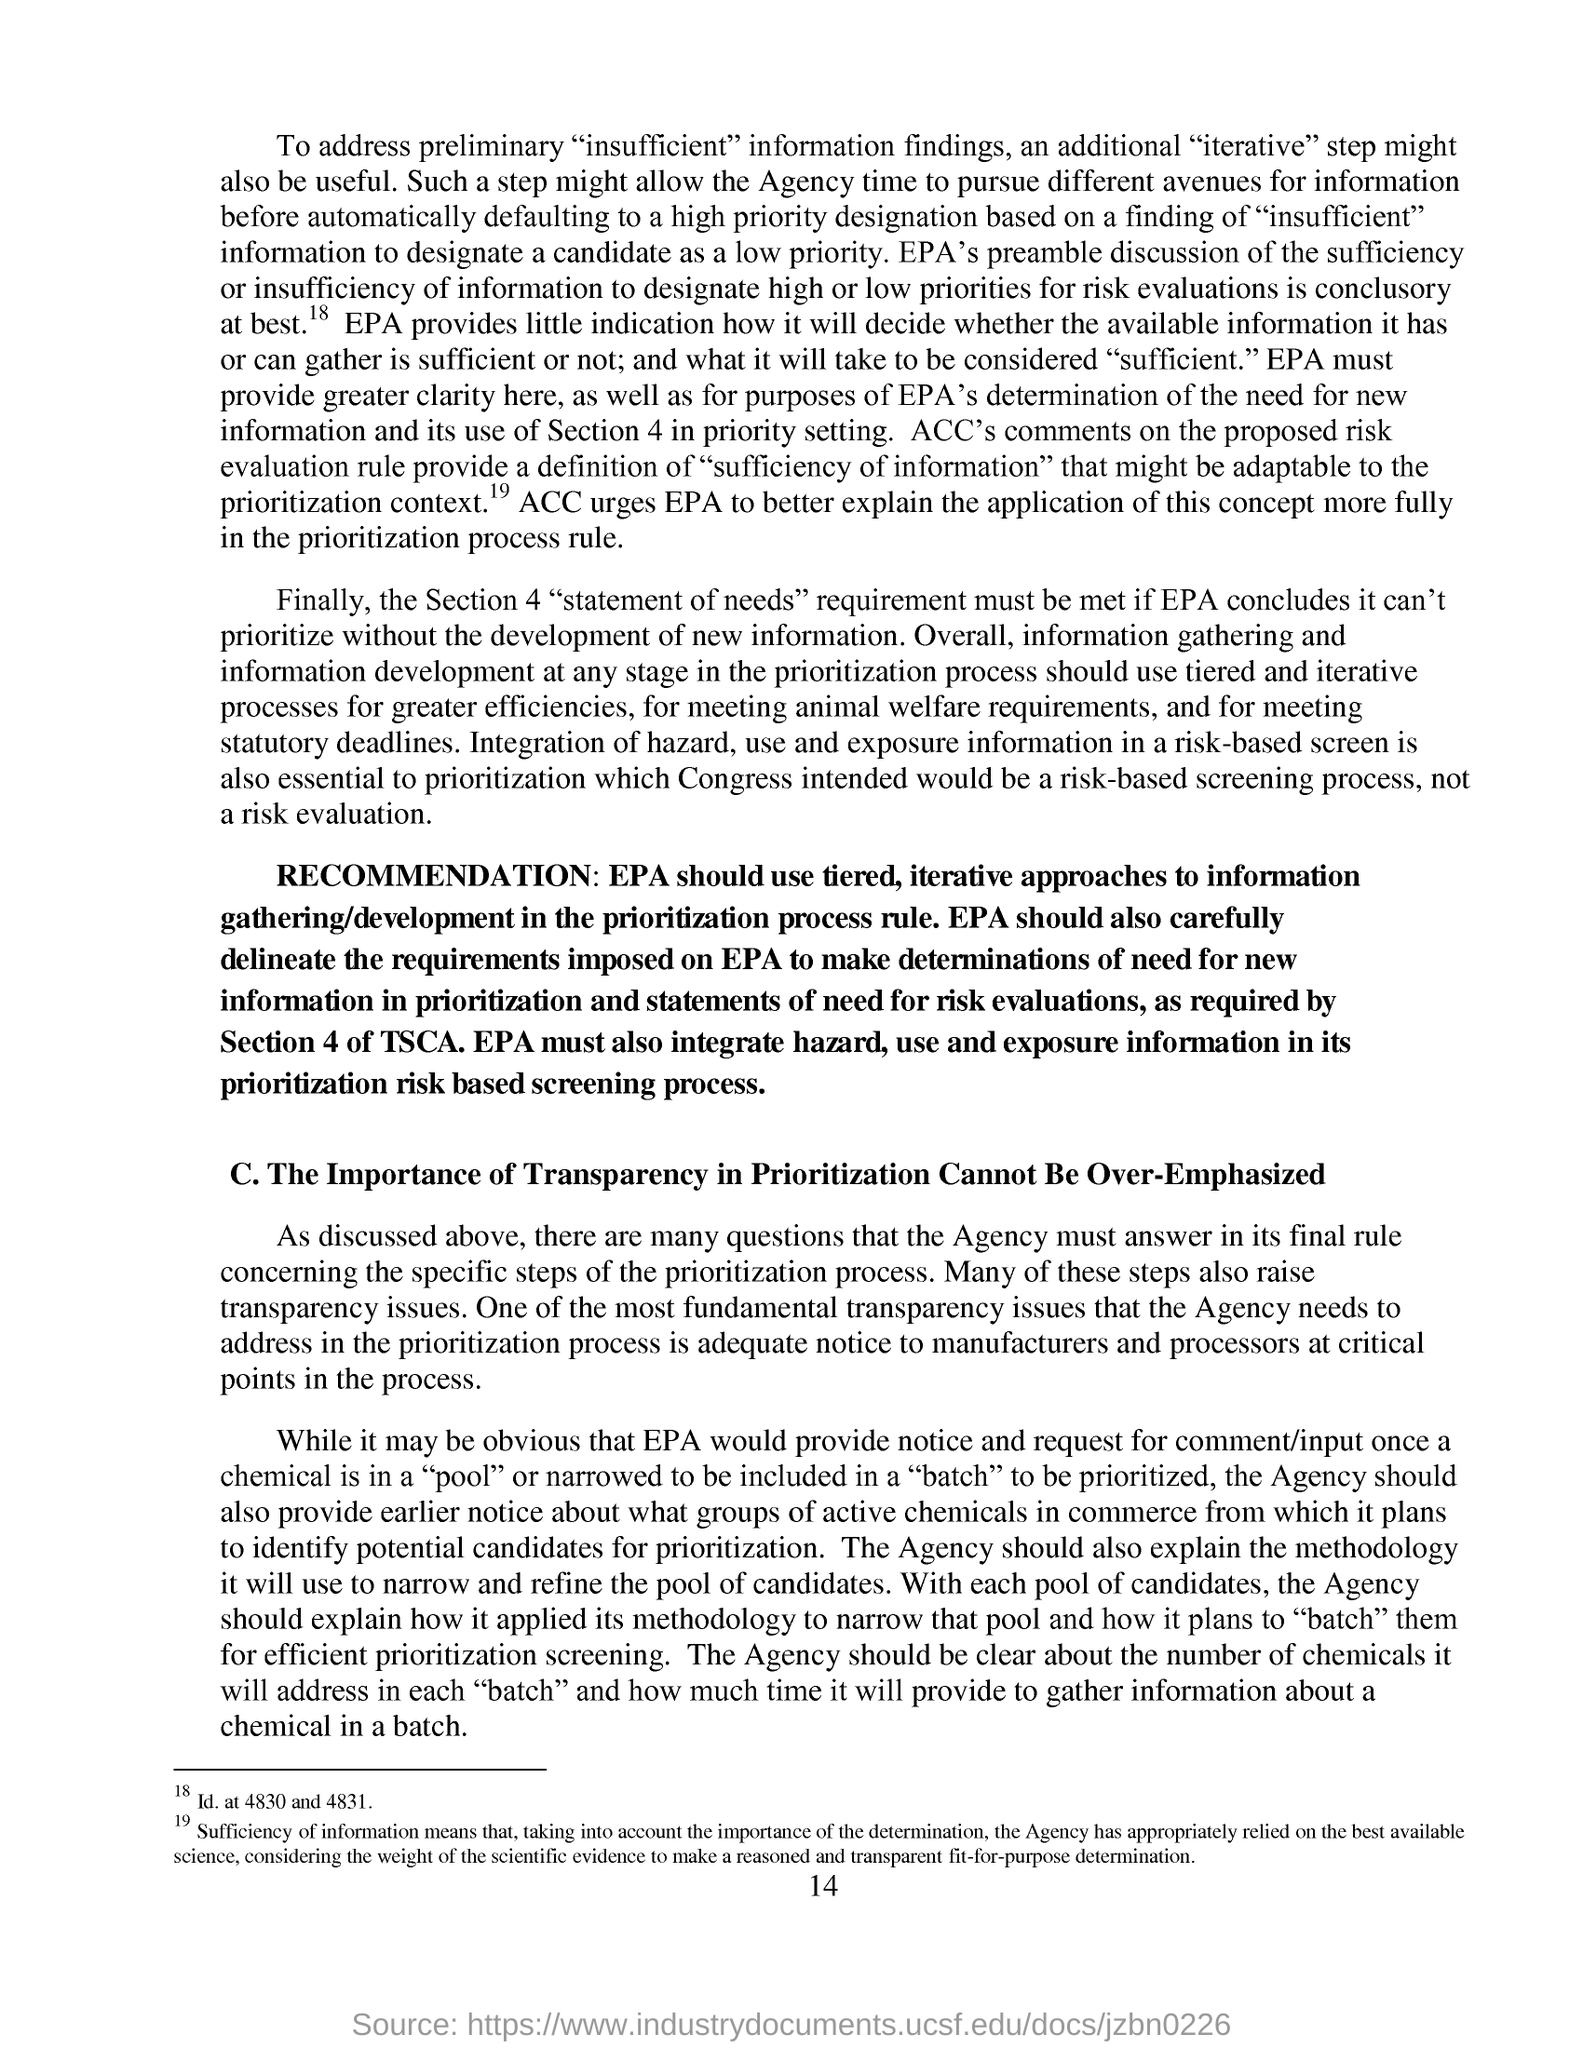What is the page no mentioned in this document?
Provide a succinct answer. 14. What is one of the most fundamental transparency issues that the agency needs to address in the prioritization process?
Ensure brevity in your answer.  Adequate notice to manufacturers and processors at critical points in the process. 